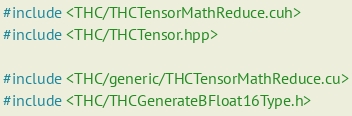<code> <loc_0><loc_0><loc_500><loc_500><_Cuda_>#include <THC/THCTensorMathReduce.cuh>
#include <THC/THCTensor.hpp>

#include <THC/generic/THCTensorMathReduce.cu>
#include <THC/THCGenerateBFloat16Type.h>
</code> 